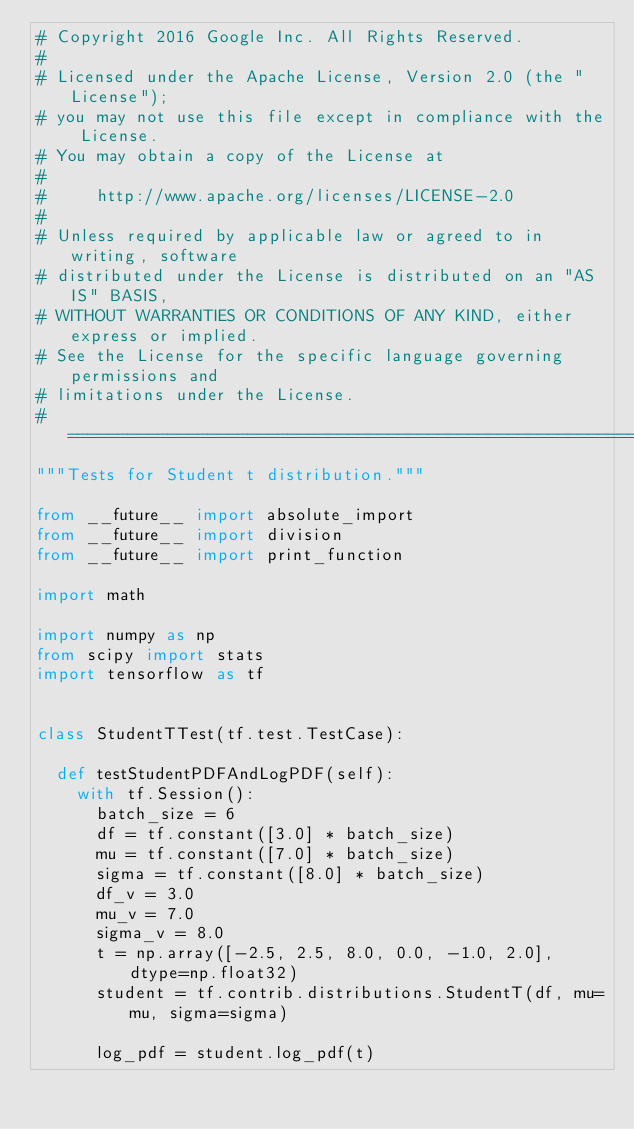Convert code to text. <code><loc_0><loc_0><loc_500><loc_500><_Python_># Copyright 2016 Google Inc. All Rights Reserved.
#
# Licensed under the Apache License, Version 2.0 (the "License");
# you may not use this file except in compliance with the License.
# You may obtain a copy of the License at
#
#     http://www.apache.org/licenses/LICENSE-2.0
#
# Unless required by applicable law or agreed to in writing, software
# distributed under the License is distributed on an "AS IS" BASIS,
# WITHOUT WARRANTIES OR CONDITIONS OF ANY KIND, either express or implied.
# See the License for the specific language governing permissions and
# limitations under the License.
# ==============================================================================
"""Tests for Student t distribution."""

from __future__ import absolute_import
from __future__ import division
from __future__ import print_function

import math

import numpy as np
from scipy import stats
import tensorflow as tf


class StudentTTest(tf.test.TestCase):

  def testStudentPDFAndLogPDF(self):
    with tf.Session():
      batch_size = 6
      df = tf.constant([3.0] * batch_size)
      mu = tf.constant([7.0] * batch_size)
      sigma = tf.constant([8.0] * batch_size)
      df_v = 3.0
      mu_v = 7.0
      sigma_v = 8.0
      t = np.array([-2.5, 2.5, 8.0, 0.0, -1.0, 2.0], dtype=np.float32)
      student = tf.contrib.distributions.StudentT(df, mu=mu, sigma=sigma)

      log_pdf = student.log_pdf(t)</code> 